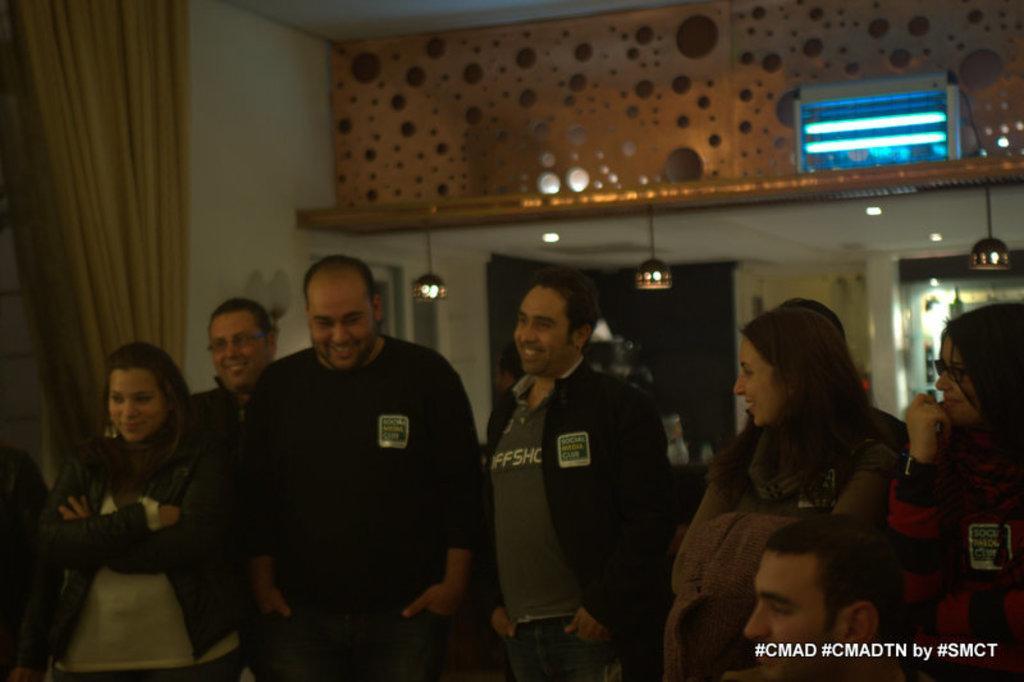Describe this image in one or two sentences. In this image there are group of people standing on the floor and watching. On the left side there is a curtain near the wall. At the top there is ceiling with the lights. 